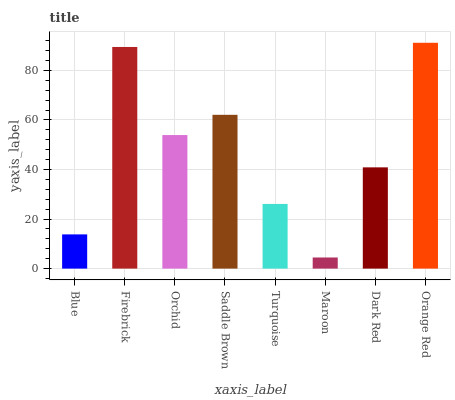Is Maroon the minimum?
Answer yes or no. Yes. Is Orange Red the maximum?
Answer yes or no. Yes. Is Firebrick the minimum?
Answer yes or no. No. Is Firebrick the maximum?
Answer yes or no. No. Is Firebrick greater than Blue?
Answer yes or no. Yes. Is Blue less than Firebrick?
Answer yes or no. Yes. Is Blue greater than Firebrick?
Answer yes or no. No. Is Firebrick less than Blue?
Answer yes or no. No. Is Orchid the high median?
Answer yes or no. Yes. Is Dark Red the low median?
Answer yes or no. Yes. Is Turquoise the high median?
Answer yes or no. No. Is Blue the low median?
Answer yes or no. No. 